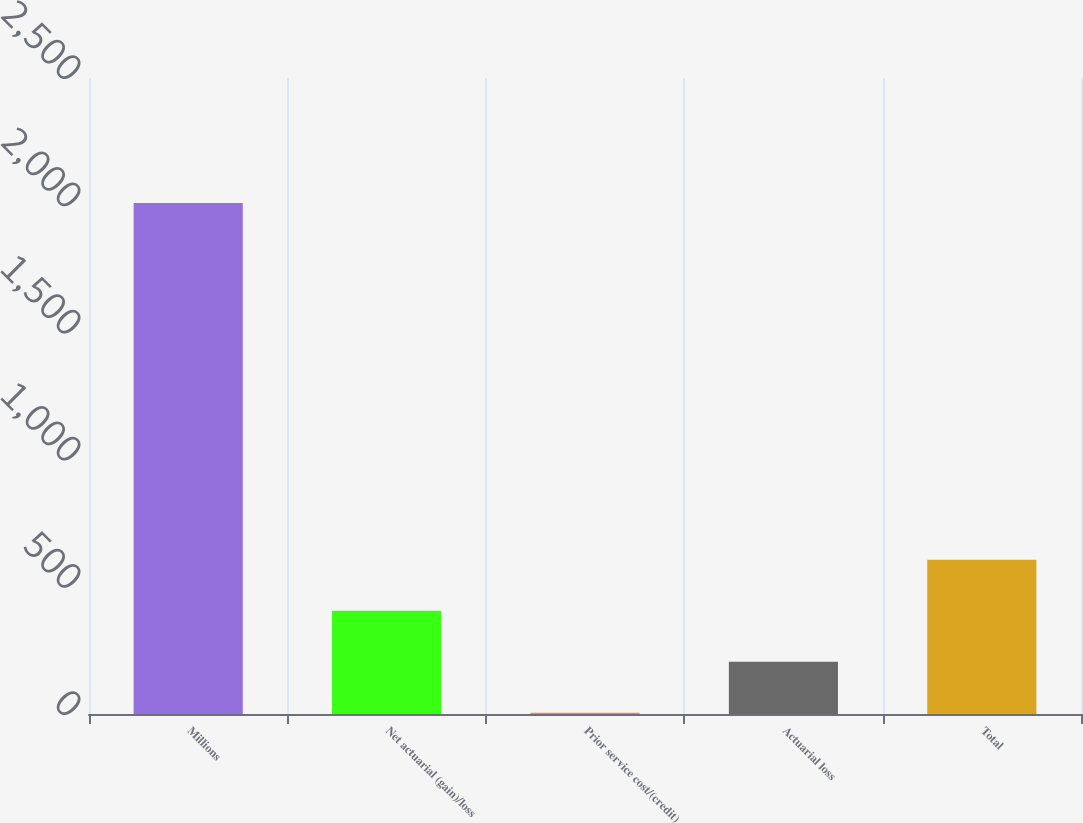Convert chart. <chart><loc_0><loc_0><loc_500><loc_500><bar_chart><fcel>Millions<fcel>Net actuarial (gain)/loss<fcel>Prior service cost/(credit)<fcel>Actuarial loss<fcel>Total<nl><fcel>2009<fcel>405.8<fcel>5<fcel>205.4<fcel>606.2<nl></chart> 